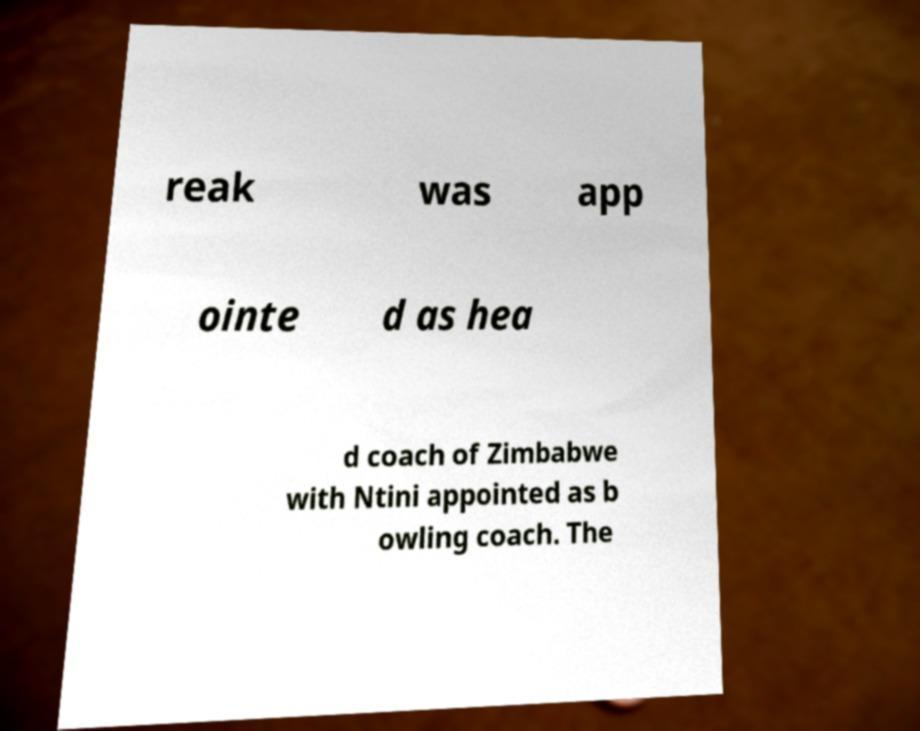Can you read and provide the text displayed in the image?This photo seems to have some interesting text. Can you extract and type it out for me? reak was app ointe d as hea d coach of Zimbabwe with Ntini appointed as b owling coach. The 